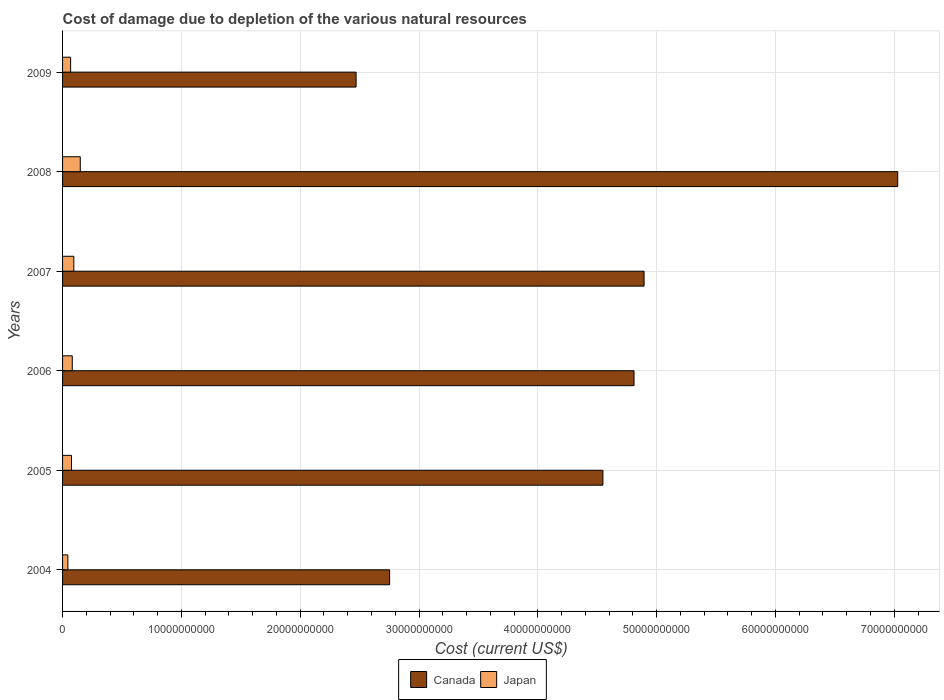How many groups of bars are there?
Your answer should be very brief. 6. How many bars are there on the 5th tick from the top?
Your answer should be compact. 2. How many bars are there on the 1st tick from the bottom?
Ensure brevity in your answer.  2. What is the label of the 2nd group of bars from the top?
Give a very brief answer. 2008. What is the cost of damage caused due to the depletion of various natural resources in Japan in 2007?
Offer a terse response. 9.47e+08. Across all years, what is the maximum cost of damage caused due to the depletion of various natural resources in Canada?
Your answer should be very brief. 7.03e+1. Across all years, what is the minimum cost of damage caused due to the depletion of various natural resources in Canada?
Offer a very short reply. 2.47e+1. In which year was the cost of damage caused due to the depletion of various natural resources in Canada minimum?
Provide a short and direct response. 2009. What is the total cost of damage caused due to the depletion of various natural resources in Canada in the graph?
Make the answer very short. 2.65e+11. What is the difference between the cost of damage caused due to the depletion of various natural resources in Canada in 2004 and that in 2005?
Make the answer very short. -1.80e+1. What is the difference between the cost of damage caused due to the depletion of various natural resources in Canada in 2008 and the cost of damage caused due to the depletion of various natural resources in Japan in 2007?
Make the answer very short. 6.93e+1. What is the average cost of damage caused due to the depletion of various natural resources in Canada per year?
Ensure brevity in your answer.  4.42e+1. In the year 2008, what is the difference between the cost of damage caused due to the depletion of various natural resources in Canada and cost of damage caused due to the depletion of various natural resources in Japan?
Offer a terse response. 6.88e+1. What is the ratio of the cost of damage caused due to the depletion of various natural resources in Japan in 2007 to that in 2008?
Provide a short and direct response. 0.64. Is the cost of damage caused due to the depletion of various natural resources in Japan in 2008 less than that in 2009?
Ensure brevity in your answer.  No. What is the difference between the highest and the second highest cost of damage caused due to the depletion of various natural resources in Canada?
Ensure brevity in your answer.  2.13e+1. What is the difference between the highest and the lowest cost of damage caused due to the depletion of various natural resources in Canada?
Ensure brevity in your answer.  4.56e+1. How many bars are there?
Provide a succinct answer. 12. Are the values on the major ticks of X-axis written in scientific E-notation?
Provide a succinct answer. No. How are the legend labels stacked?
Your response must be concise. Horizontal. What is the title of the graph?
Your answer should be very brief. Cost of damage due to depletion of the various natural resources. Does "South Asia" appear as one of the legend labels in the graph?
Give a very brief answer. No. What is the label or title of the X-axis?
Provide a short and direct response. Cost (current US$). What is the label or title of the Y-axis?
Ensure brevity in your answer.  Years. What is the Cost (current US$) in Canada in 2004?
Your answer should be compact. 2.75e+1. What is the Cost (current US$) in Japan in 2004?
Provide a short and direct response. 4.48e+08. What is the Cost (current US$) in Canada in 2005?
Your response must be concise. 4.55e+1. What is the Cost (current US$) in Japan in 2005?
Your answer should be compact. 7.53e+08. What is the Cost (current US$) of Canada in 2006?
Your response must be concise. 4.81e+1. What is the Cost (current US$) in Japan in 2006?
Your answer should be compact. 8.17e+08. What is the Cost (current US$) of Canada in 2007?
Make the answer very short. 4.89e+1. What is the Cost (current US$) of Japan in 2007?
Give a very brief answer. 9.47e+08. What is the Cost (current US$) of Canada in 2008?
Offer a very short reply. 7.03e+1. What is the Cost (current US$) of Japan in 2008?
Your answer should be very brief. 1.49e+09. What is the Cost (current US$) of Canada in 2009?
Make the answer very short. 2.47e+1. What is the Cost (current US$) in Japan in 2009?
Give a very brief answer. 6.78e+08. Across all years, what is the maximum Cost (current US$) of Canada?
Provide a short and direct response. 7.03e+1. Across all years, what is the maximum Cost (current US$) of Japan?
Your answer should be very brief. 1.49e+09. Across all years, what is the minimum Cost (current US$) of Canada?
Your answer should be very brief. 2.47e+1. Across all years, what is the minimum Cost (current US$) in Japan?
Ensure brevity in your answer.  4.48e+08. What is the total Cost (current US$) of Canada in the graph?
Offer a terse response. 2.65e+11. What is the total Cost (current US$) in Japan in the graph?
Your answer should be compact. 5.13e+09. What is the difference between the Cost (current US$) of Canada in 2004 and that in 2005?
Provide a short and direct response. -1.80e+1. What is the difference between the Cost (current US$) of Japan in 2004 and that in 2005?
Your response must be concise. -3.05e+08. What is the difference between the Cost (current US$) of Canada in 2004 and that in 2006?
Your answer should be very brief. -2.06e+1. What is the difference between the Cost (current US$) of Japan in 2004 and that in 2006?
Make the answer very short. -3.69e+08. What is the difference between the Cost (current US$) in Canada in 2004 and that in 2007?
Keep it short and to the point. -2.14e+1. What is the difference between the Cost (current US$) in Japan in 2004 and that in 2007?
Provide a succinct answer. -4.99e+08. What is the difference between the Cost (current US$) in Canada in 2004 and that in 2008?
Offer a terse response. -4.28e+1. What is the difference between the Cost (current US$) in Japan in 2004 and that in 2008?
Give a very brief answer. -1.04e+09. What is the difference between the Cost (current US$) of Canada in 2004 and that in 2009?
Provide a short and direct response. 2.82e+09. What is the difference between the Cost (current US$) of Japan in 2004 and that in 2009?
Give a very brief answer. -2.30e+08. What is the difference between the Cost (current US$) in Canada in 2005 and that in 2006?
Your answer should be compact. -2.62e+09. What is the difference between the Cost (current US$) of Japan in 2005 and that in 2006?
Ensure brevity in your answer.  -6.37e+07. What is the difference between the Cost (current US$) of Canada in 2005 and that in 2007?
Offer a very short reply. -3.46e+09. What is the difference between the Cost (current US$) of Japan in 2005 and that in 2007?
Make the answer very short. -1.94e+08. What is the difference between the Cost (current US$) in Canada in 2005 and that in 2008?
Ensure brevity in your answer.  -2.48e+1. What is the difference between the Cost (current US$) of Japan in 2005 and that in 2008?
Make the answer very short. -7.37e+08. What is the difference between the Cost (current US$) in Canada in 2005 and that in 2009?
Ensure brevity in your answer.  2.08e+1. What is the difference between the Cost (current US$) of Japan in 2005 and that in 2009?
Provide a succinct answer. 7.52e+07. What is the difference between the Cost (current US$) in Canada in 2006 and that in 2007?
Ensure brevity in your answer.  -8.46e+08. What is the difference between the Cost (current US$) in Japan in 2006 and that in 2007?
Offer a very short reply. -1.30e+08. What is the difference between the Cost (current US$) of Canada in 2006 and that in 2008?
Your response must be concise. -2.22e+1. What is the difference between the Cost (current US$) of Japan in 2006 and that in 2008?
Your answer should be compact. -6.74e+08. What is the difference between the Cost (current US$) of Canada in 2006 and that in 2009?
Provide a short and direct response. 2.34e+1. What is the difference between the Cost (current US$) in Japan in 2006 and that in 2009?
Your response must be concise. 1.39e+08. What is the difference between the Cost (current US$) in Canada in 2007 and that in 2008?
Provide a short and direct response. -2.13e+1. What is the difference between the Cost (current US$) of Japan in 2007 and that in 2008?
Ensure brevity in your answer.  -5.43e+08. What is the difference between the Cost (current US$) of Canada in 2007 and that in 2009?
Offer a very short reply. 2.42e+1. What is the difference between the Cost (current US$) of Japan in 2007 and that in 2009?
Offer a very short reply. 2.69e+08. What is the difference between the Cost (current US$) of Canada in 2008 and that in 2009?
Offer a very short reply. 4.56e+1. What is the difference between the Cost (current US$) of Japan in 2008 and that in 2009?
Keep it short and to the point. 8.13e+08. What is the difference between the Cost (current US$) of Canada in 2004 and the Cost (current US$) of Japan in 2005?
Your response must be concise. 2.68e+1. What is the difference between the Cost (current US$) of Canada in 2004 and the Cost (current US$) of Japan in 2006?
Offer a very short reply. 2.67e+1. What is the difference between the Cost (current US$) in Canada in 2004 and the Cost (current US$) in Japan in 2007?
Offer a very short reply. 2.66e+1. What is the difference between the Cost (current US$) in Canada in 2004 and the Cost (current US$) in Japan in 2008?
Keep it short and to the point. 2.60e+1. What is the difference between the Cost (current US$) of Canada in 2004 and the Cost (current US$) of Japan in 2009?
Your answer should be very brief. 2.68e+1. What is the difference between the Cost (current US$) in Canada in 2005 and the Cost (current US$) in Japan in 2006?
Your response must be concise. 4.47e+1. What is the difference between the Cost (current US$) in Canada in 2005 and the Cost (current US$) in Japan in 2007?
Provide a succinct answer. 4.45e+1. What is the difference between the Cost (current US$) in Canada in 2005 and the Cost (current US$) in Japan in 2008?
Your answer should be compact. 4.40e+1. What is the difference between the Cost (current US$) in Canada in 2005 and the Cost (current US$) in Japan in 2009?
Offer a terse response. 4.48e+1. What is the difference between the Cost (current US$) of Canada in 2006 and the Cost (current US$) of Japan in 2007?
Ensure brevity in your answer.  4.72e+1. What is the difference between the Cost (current US$) in Canada in 2006 and the Cost (current US$) in Japan in 2008?
Your response must be concise. 4.66e+1. What is the difference between the Cost (current US$) in Canada in 2006 and the Cost (current US$) in Japan in 2009?
Offer a very short reply. 4.74e+1. What is the difference between the Cost (current US$) of Canada in 2007 and the Cost (current US$) of Japan in 2008?
Make the answer very short. 4.75e+1. What is the difference between the Cost (current US$) in Canada in 2007 and the Cost (current US$) in Japan in 2009?
Your answer should be very brief. 4.83e+1. What is the difference between the Cost (current US$) of Canada in 2008 and the Cost (current US$) of Japan in 2009?
Provide a short and direct response. 6.96e+1. What is the average Cost (current US$) of Canada per year?
Your answer should be compact. 4.42e+1. What is the average Cost (current US$) of Japan per year?
Offer a very short reply. 8.56e+08. In the year 2004, what is the difference between the Cost (current US$) of Canada and Cost (current US$) of Japan?
Keep it short and to the point. 2.71e+1. In the year 2005, what is the difference between the Cost (current US$) of Canada and Cost (current US$) of Japan?
Your response must be concise. 4.47e+1. In the year 2006, what is the difference between the Cost (current US$) of Canada and Cost (current US$) of Japan?
Your answer should be very brief. 4.73e+1. In the year 2007, what is the difference between the Cost (current US$) in Canada and Cost (current US$) in Japan?
Give a very brief answer. 4.80e+1. In the year 2008, what is the difference between the Cost (current US$) of Canada and Cost (current US$) of Japan?
Give a very brief answer. 6.88e+1. In the year 2009, what is the difference between the Cost (current US$) in Canada and Cost (current US$) in Japan?
Offer a very short reply. 2.40e+1. What is the ratio of the Cost (current US$) in Canada in 2004 to that in 2005?
Provide a succinct answer. 0.61. What is the ratio of the Cost (current US$) of Japan in 2004 to that in 2005?
Provide a succinct answer. 0.59. What is the ratio of the Cost (current US$) of Canada in 2004 to that in 2006?
Your answer should be compact. 0.57. What is the ratio of the Cost (current US$) in Japan in 2004 to that in 2006?
Offer a terse response. 0.55. What is the ratio of the Cost (current US$) in Canada in 2004 to that in 2007?
Ensure brevity in your answer.  0.56. What is the ratio of the Cost (current US$) in Japan in 2004 to that in 2007?
Provide a short and direct response. 0.47. What is the ratio of the Cost (current US$) of Canada in 2004 to that in 2008?
Offer a terse response. 0.39. What is the ratio of the Cost (current US$) in Japan in 2004 to that in 2008?
Your answer should be compact. 0.3. What is the ratio of the Cost (current US$) in Canada in 2004 to that in 2009?
Offer a terse response. 1.11. What is the ratio of the Cost (current US$) of Japan in 2004 to that in 2009?
Provide a short and direct response. 0.66. What is the ratio of the Cost (current US$) of Canada in 2005 to that in 2006?
Your response must be concise. 0.95. What is the ratio of the Cost (current US$) of Japan in 2005 to that in 2006?
Keep it short and to the point. 0.92. What is the ratio of the Cost (current US$) of Canada in 2005 to that in 2007?
Your response must be concise. 0.93. What is the ratio of the Cost (current US$) of Japan in 2005 to that in 2007?
Keep it short and to the point. 0.8. What is the ratio of the Cost (current US$) of Canada in 2005 to that in 2008?
Give a very brief answer. 0.65. What is the ratio of the Cost (current US$) in Japan in 2005 to that in 2008?
Ensure brevity in your answer.  0.51. What is the ratio of the Cost (current US$) in Canada in 2005 to that in 2009?
Ensure brevity in your answer.  1.84. What is the ratio of the Cost (current US$) of Japan in 2005 to that in 2009?
Offer a terse response. 1.11. What is the ratio of the Cost (current US$) in Canada in 2006 to that in 2007?
Offer a terse response. 0.98. What is the ratio of the Cost (current US$) in Japan in 2006 to that in 2007?
Your answer should be very brief. 0.86. What is the ratio of the Cost (current US$) in Canada in 2006 to that in 2008?
Give a very brief answer. 0.68. What is the ratio of the Cost (current US$) in Japan in 2006 to that in 2008?
Ensure brevity in your answer.  0.55. What is the ratio of the Cost (current US$) of Canada in 2006 to that in 2009?
Provide a succinct answer. 1.95. What is the ratio of the Cost (current US$) of Japan in 2006 to that in 2009?
Your answer should be very brief. 1.2. What is the ratio of the Cost (current US$) in Canada in 2007 to that in 2008?
Your answer should be compact. 0.7. What is the ratio of the Cost (current US$) in Japan in 2007 to that in 2008?
Give a very brief answer. 0.64. What is the ratio of the Cost (current US$) in Canada in 2007 to that in 2009?
Your response must be concise. 1.98. What is the ratio of the Cost (current US$) in Japan in 2007 to that in 2009?
Your response must be concise. 1.4. What is the ratio of the Cost (current US$) of Canada in 2008 to that in 2009?
Your answer should be compact. 2.85. What is the ratio of the Cost (current US$) of Japan in 2008 to that in 2009?
Ensure brevity in your answer.  2.2. What is the difference between the highest and the second highest Cost (current US$) in Canada?
Your response must be concise. 2.13e+1. What is the difference between the highest and the second highest Cost (current US$) in Japan?
Your answer should be very brief. 5.43e+08. What is the difference between the highest and the lowest Cost (current US$) of Canada?
Your answer should be compact. 4.56e+1. What is the difference between the highest and the lowest Cost (current US$) in Japan?
Your answer should be very brief. 1.04e+09. 